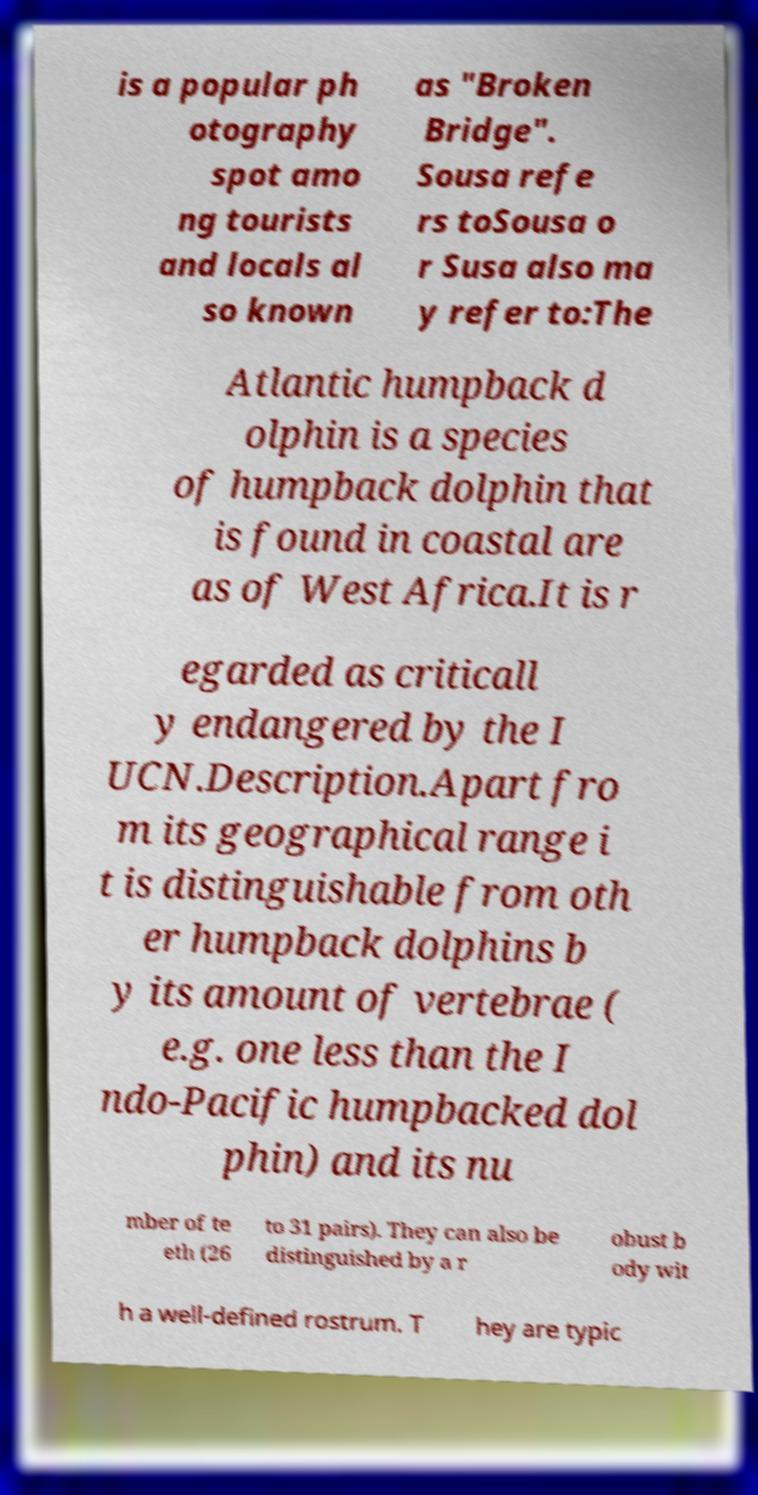I need the written content from this picture converted into text. Can you do that? is a popular ph otography spot amo ng tourists and locals al so known as "Broken Bridge". Sousa refe rs toSousa o r Susa also ma y refer to:The Atlantic humpback d olphin is a species of humpback dolphin that is found in coastal are as of West Africa.It is r egarded as criticall y endangered by the I UCN.Description.Apart fro m its geographical range i t is distinguishable from oth er humpback dolphins b y its amount of vertebrae ( e.g. one less than the I ndo-Pacific humpbacked dol phin) and its nu mber of te eth (26 to 31 pairs). They can also be distinguished by a r obust b ody wit h a well-defined rostrum. T hey are typic 